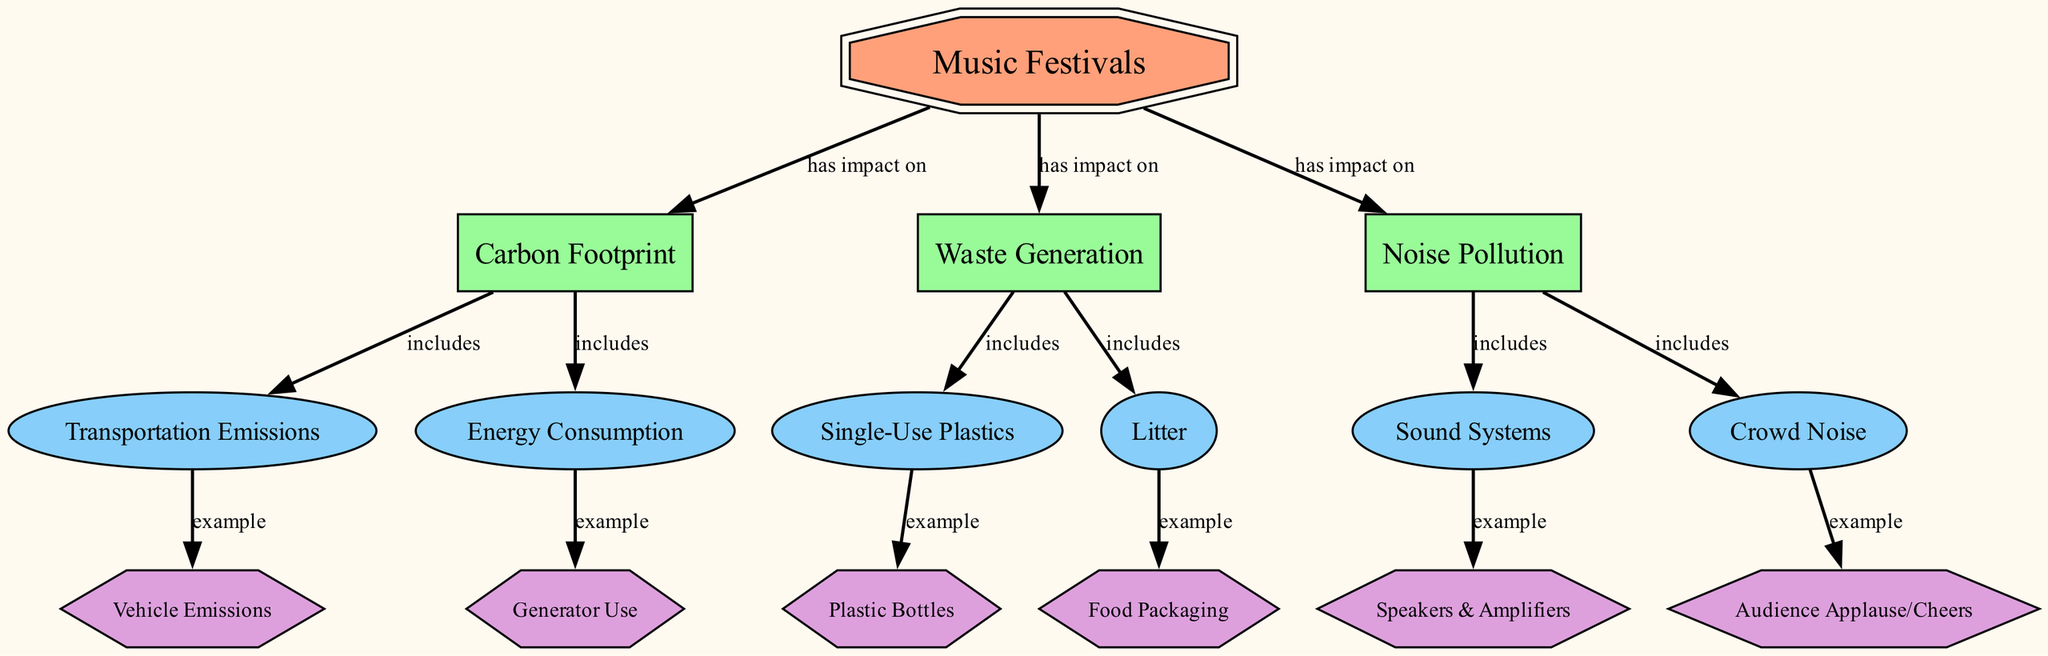What are the main impacts of music festivals? The diagram shows that music festivals have three main impacts: carbon footprint, waste generation, and noise pollution. These are directly linked to the central concept of music festivals.
Answer: carbon footprint, waste generation, noise pollution What is included in the carbon footprint category? According to the diagram, the carbon footprint category includes transportation emissions and energy consumption. This is indicated by the "includes" relationship from carbon footprint to its sub-categories.
Answer: transportation emissions, energy consumption How many nodes are classified as real-world entities? The diagram includes four nodes classified as real-world entities: vehicle emissions, generator use, plastic bottles, food packaging, speakers & amplifiers, and audience applause/cheers. Therefore, there are six real-world entities.
Answer: 6 What examples are given for waste generation? The diagram indicates that waste generation is exemplified by single-use plastics and litter. These are specific instances listed under the waste generation category.
Answer: single-use plastics, litter Which sub-impact is associated with noise pollution? The diagram illustrates that noise pollution is associated with sound systems and crowd noise as its sub-impacts. This is derived from the direct connection shown under the noise pollution category.
Answer: sound systems, crowd noise What is the relationship between music festivals and noise pollution? The relationship depicted in the diagram shows that music festivals have an impact on noise pollution, represented by a direct edge connecting them.
Answer: has impact on Which specific example falls under energy consumption? The diagram specifies "generator use" as an example that falls under the energy consumption sub-impact category. This is a clear relationship indicated in the diagram.
Answer: generator use What kind of waste is categorized under litter? According to the diagram, "food packaging" is categorized under litter as a specific example of waste generation that falls under the litter sub-impact.
Answer: food packaging 